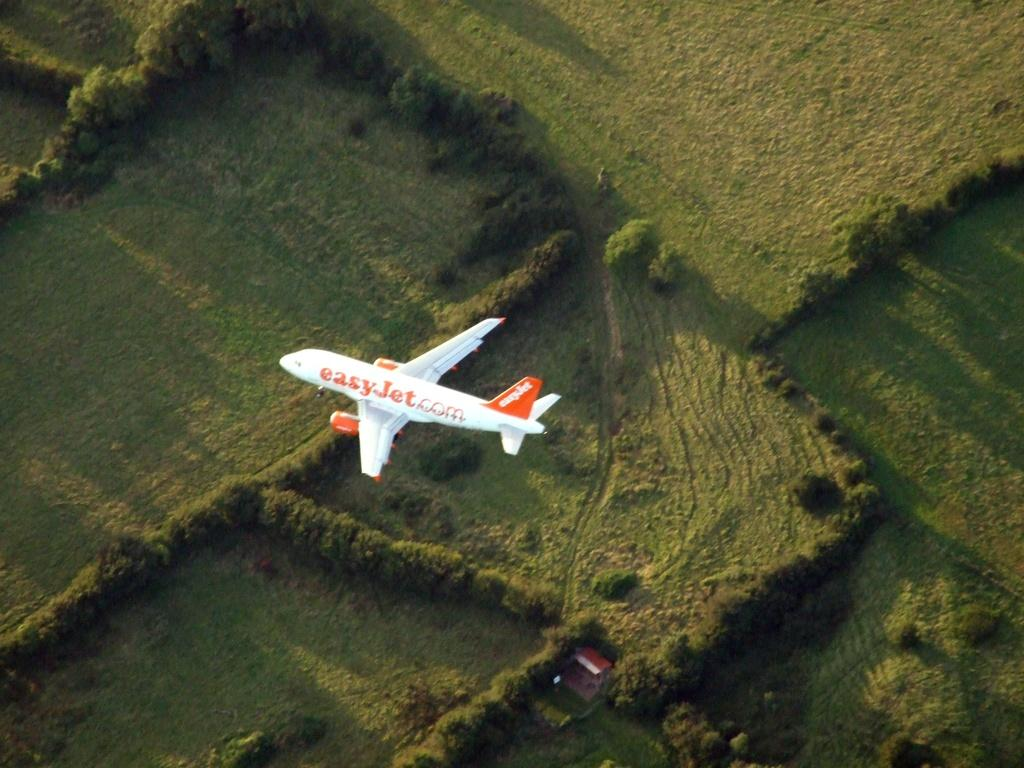<image>
Provide a brief description of the given image. a plane that has easyjet.com on the side of it 